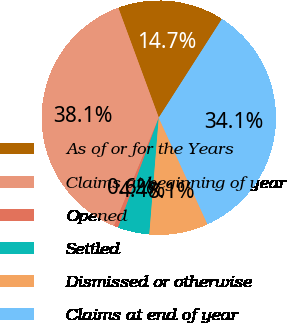Convert chart to OTSL. <chart><loc_0><loc_0><loc_500><loc_500><pie_chart><fcel>As of or for the Years<fcel>Claims at beginning of year<fcel>Opened<fcel>Settled<fcel>Dismissed or otherwise<fcel>Claims at end of year<nl><fcel>14.68%<fcel>38.13%<fcel>0.61%<fcel>4.36%<fcel>8.11%<fcel>34.12%<nl></chart> 